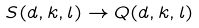Convert formula to latex. <formula><loc_0><loc_0><loc_500><loc_500>S ( d , k , l ) \to Q ( d , k , l )</formula> 